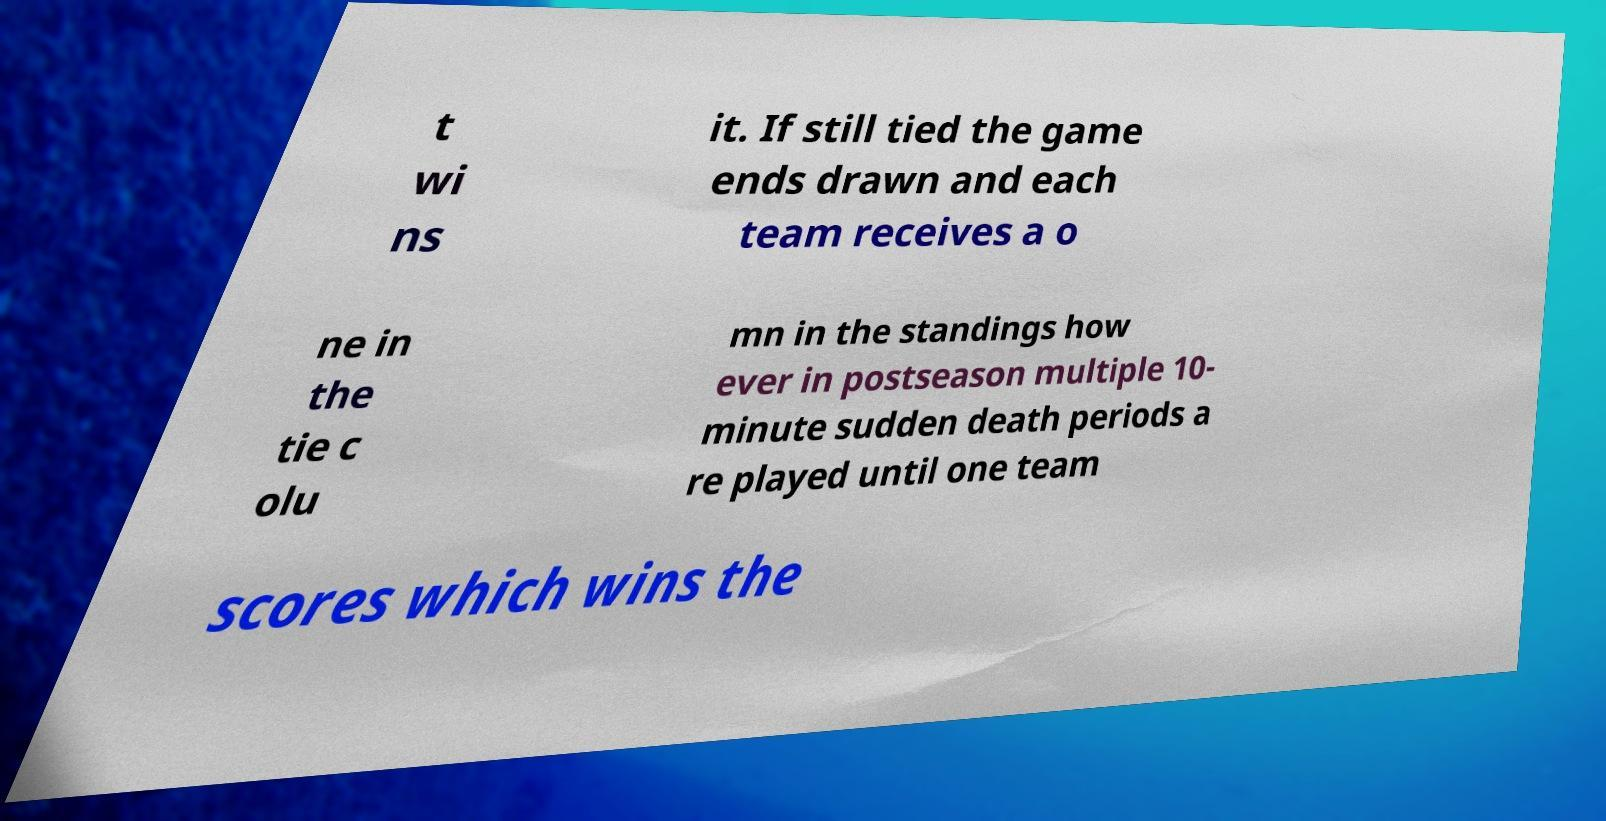For documentation purposes, I need the text within this image transcribed. Could you provide that? t wi ns it. If still tied the game ends drawn and each team receives a o ne in the tie c olu mn in the standings how ever in postseason multiple 10- minute sudden death periods a re played until one team scores which wins the 